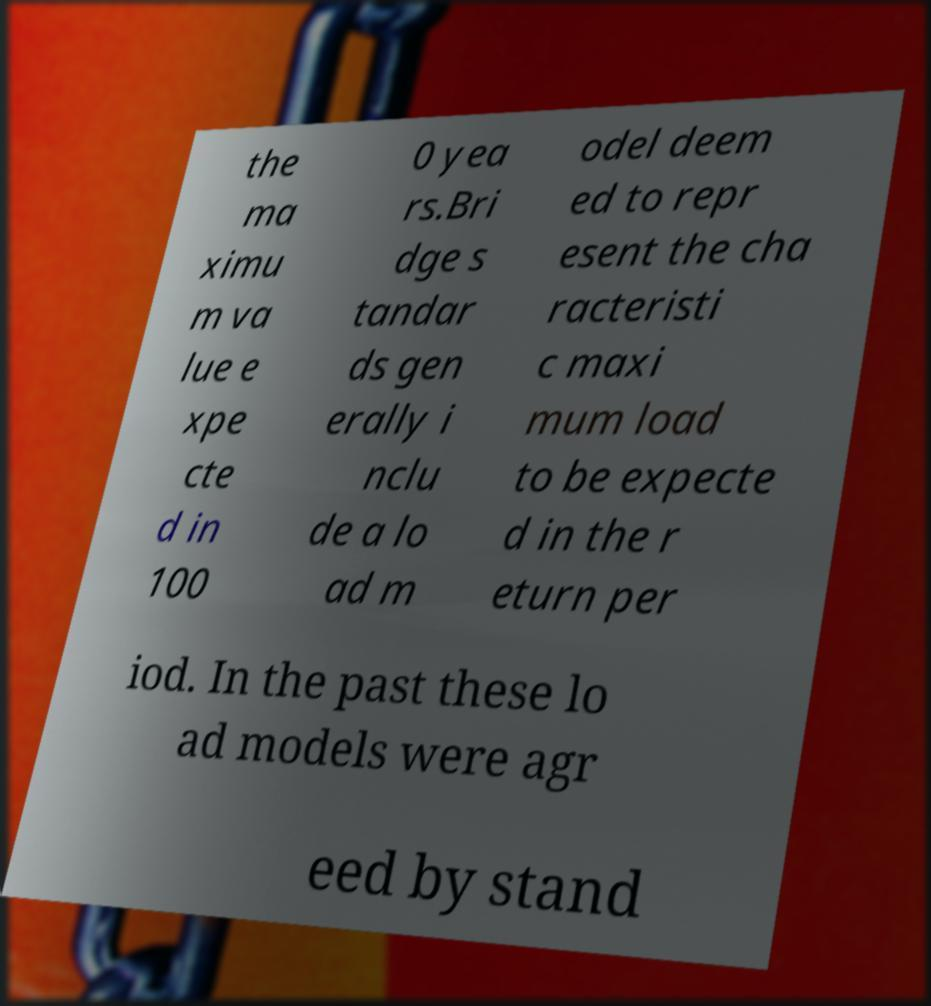For documentation purposes, I need the text within this image transcribed. Could you provide that? the ma ximu m va lue e xpe cte d in 100 0 yea rs.Bri dge s tandar ds gen erally i nclu de a lo ad m odel deem ed to repr esent the cha racteristi c maxi mum load to be expecte d in the r eturn per iod. In the past these lo ad models were agr eed by stand 